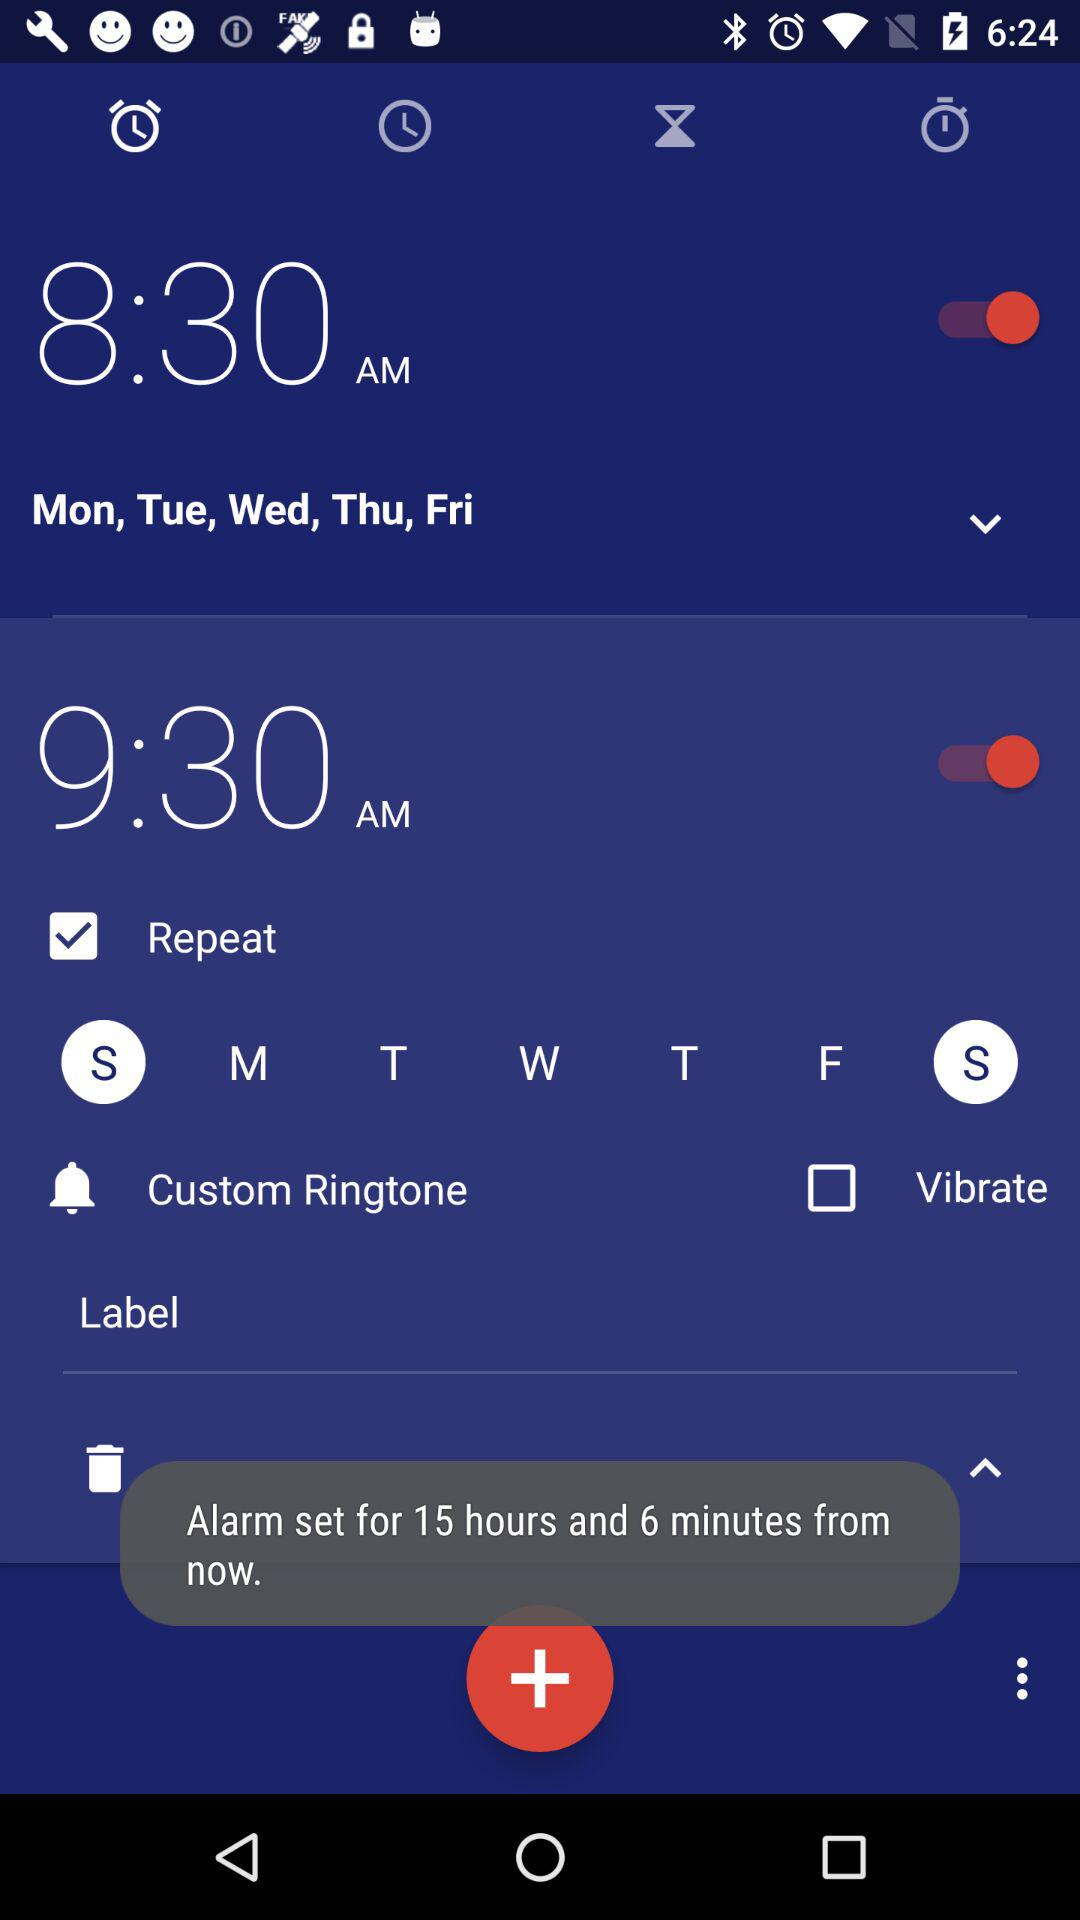How many hours is the difference between the two alarm times?
Answer the question using a single word or phrase. 1 hour 